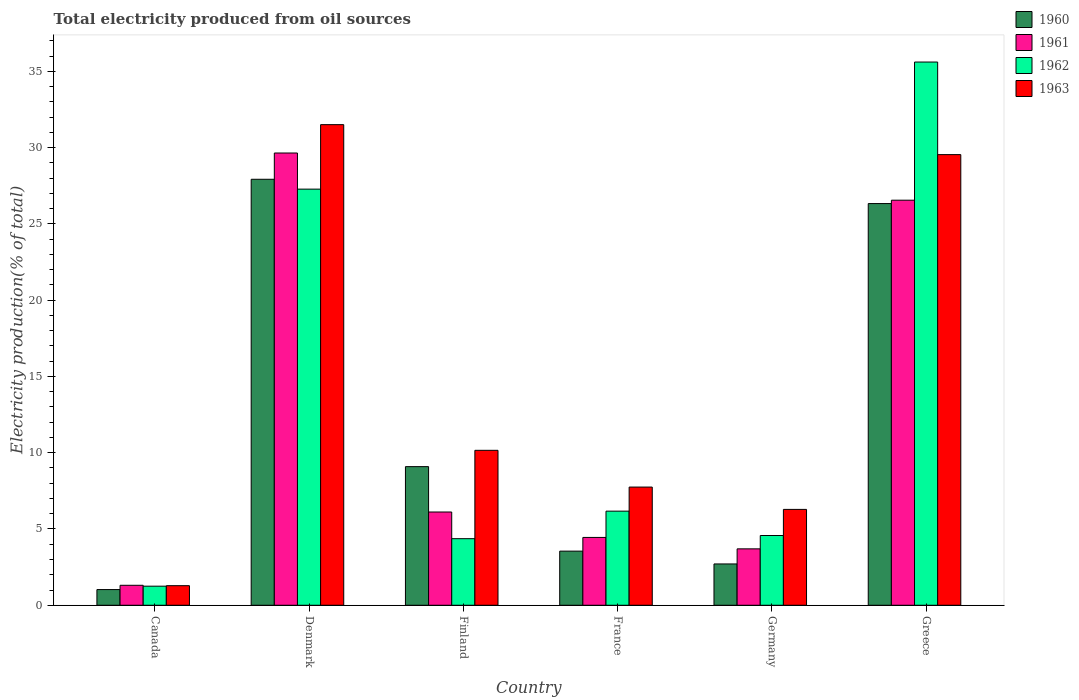How many groups of bars are there?
Provide a short and direct response. 6. Are the number of bars per tick equal to the number of legend labels?
Give a very brief answer. Yes. Are the number of bars on each tick of the X-axis equal?
Provide a succinct answer. Yes. How many bars are there on the 2nd tick from the left?
Your answer should be very brief. 4. How many bars are there on the 6th tick from the right?
Keep it short and to the point. 4. What is the total electricity produced in 1962 in Canada?
Your answer should be compact. 1.25. Across all countries, what is the maximum total electricity produced in 1960?
Your answer should be compact. 27.92. Across all countries, what is the minimum total electricity produced in 1963?
Your response must be concise. 1.28. In which country was the total electricity produced in 1960 minimum?
Provide a succinct answer. Canada. What is the total total electricity produced in 1960 in the graph?
Give a very brief answer. 70.63. What is the difference between the total electricity produced in 1961 in Denmark and that in Greece?
Keep it short and to the point. 3.09. What is the difference between the total electricity produced in 1960 in Canada and the total electricity produced in 1961 in Greece?
Provide a succinct answer. -25.52. What is the average total electricity produced in 1962 per country?
Offer a terse response. 13.21. What is the difference between the total electricity produced of/in 1960 and total electricity produced of/in 1962 in Germany?
Give a very brief answer. -1.86. In how many countries, is the total electricity produced in 1963 greater than 1 %?
Give a very brief answer. 6. What is the ratio of the total electricity produced in 1960 in Canada to that in Finland?
Provide a short and direct response. 0.11. Is the total electricity produced in 1962 in Canada less than that in Germany?
Keep it short and to the point. Yes. Is the difference between the total electricity produced in 1960 in Finland and Germany greater than the difference between the total electricity produced in 1962 in Finland and Germany?
Your answer should be very brief. Yes. What is the difference between the highest and the second highest total electricity produced in 1960?
Provide a short and direct response. -17.24. What is the difference between the highest and the lowest total electricity produced in 1963?
Provide a short and direct response. 30.22. In how many countries, is the total electricity produced in 1962 greater than the average total electricity produced in 1962 taken over all countries?
Your answer should be compact. 2. Is the sum of the total electricity produced in 1961 in Denmark and Germany greater than the maximum total electricity produced in 1962 across all countries?
Your answer should be very brief. No. What does the 1st bar from the right in Greece represents?
Your answer should be compact. 1963. How many bars are there?
Your answer should be compact. 24. Are all the bars in the graph horizontal?
Ensure brevity in your answer.  No. Are the values on the major ticks of Y-axis written in scientific E-notation?
Your answer should be very brief. No. Where does the legend appear in the graph?
Your answer should be compact. Top right. How many legend labels are there?
Your answer should be compact. 4. What is the title of the graph?
Your answer should be very brief. Total electricity produced from oil sources. What is the label or title of the Y-axis?
Your answer should be very brief. Electricity production(% of total). What is the Electricity production(% of total) in 1960 in Canada?
Ensure brevity in your answer.  1.03. What is the Electricity production(% of total) in 1961 in Canada?
Ensure brevity in your answer.  1.31. What is the Electricity production(% of total) in 1962 in Canada?
Offer a very short reply. 1.25. What is the Electricity production(% of total) of 1963 in Canada?
Offer a terse response. 1.28. What is the Electricity production(% of total) of 1960 in Denmark?
Give a very brief answer. 27.92. What is the Electricity production(% of total) in 1961 in Denmark?
Provide a succinct answer. 29.65. What is the Electricity production(% of total) in 1962 in Denmark?
Give a very brief answer. 27.28. What is the Electricity production(% of total) of 1963 in Denmark?
Your answer should be very brief. 31.51. What is the Electricity production(% of total) in 1960 in Finland?
Give a very brief answer. 9.09. What is the Electricity production(% of total) in 1961 in Finland?
Your response must be concise. 6.11. What is the Electricity production(% of total) of 1962 in Finland?
Provide a succinct answer. 4.36. What is the Electricity production(% of total) of 1963 in Finland?
Give a very brief answer. 10.16. What is the Electricity production(% of total) of 1960 in France?
Your answer should be very brief. 3.55. What is the Electricity production(% of total) of 1961 in France?
Your answer should be compact. 4.45. What is the Electricity production(% of total) of 1962 in France?
Provide a succinct answer. 6.17. What is the Electricity production(% of total) of 1963 in France?
Offer a terse response. 7.75. What is the Electricity production(% of total) of 1960 in Germany?
Keep it short and to the point. 2.71. What is the Electricity production(% of total) of 1961 in Germany?
Give a very brief answer. 3.7. What is the Electricity production(% of total) of 1962 in Germany?
Ensure brevity in your answer.  4.57. What is the Electricity production(% of total) in 1963 in Germany?
Provide a succinct answer. 6.28. What is the Electricity production(% of total) of 1960 in Greece?
Your answer should be compact. 26.33. What is the Electricity production(% of total) of 1961 in Greece?
Offer a very short reply. 26.55. What is the Electricity production(% of total) of 1962 in Greece?
Offer a terse response. 35.61. What is the Electricity production(% of total) in 1963 in Greece?
Keep it short and to the point. 29.54. Across all countries, what is the maximum Electricity production(% of total) of 1960?
Your answer should be compact. 27.92. Across all countries, what is the maximum Electricity production(% of total) in 1961?
Make the answer very short. 29.65. Across all countries, what is the maximum Electricity production(% of total) of 1962?
Provide a short and direct response. 35.61. Across all countries, what is the maximum Electricity production(% of total) in 1963?
Make the answer very short. 31.51. Across all countries, what is the minimum Electricity production(% of total) in 1960?
Ensure brevity in your answer.  1.03. Across all countries, what is the minimum Electricity production(% of total) in 1961?
Your response must be concise. 1.31. Across all countries, what is the minimum Electricity production(% of total) in 1962?
Your answer should be compact. 1.25. Across all countries, what is the minimum Electricity production(% of total) in 1963?
Offer a very short reply. 1.28. What is the total Electricity production(% of total) of 1960 in the graph?
Keep it short and to the point. 70.63. What is the total Electricity production(% of total) of 1961 in the graph?
Your response must be concise. 71.77. What is the total Electricity production(% of total) in 1962 in the graph?
Make the answer very short. 79.25. What is the total Electricity production(% of total) of 1963 in the graph?
Ensure brevity in your answer.  86.52. What is the difference between the Electricity production(% of total) in 1960 in Canada and that in Denmark?
Provide a succinct answer. -26.9. What is the difference between the Electricity production(% of total) in 1961 in Canada and that in Denmark?
Provide a succinct answer. -28.34. What is the difference between the Electricity production(% of total) in 1962 in Canada and that in Denmark?
Your response must be concise. -26.03. What is the difference between the Electricity production(% of total) in 1963 in Canada and that in Denmark?
Your answer should be very brief. -30.22. What is the difference between the Electricity production(% of total) in 1960 in Canada and that in Finland?
Your response must be concise. -8.06. What is the difference between the Electricity production(% of total) of 1961 in Canada and that in Finland?
Your answer should be very brief. -4.8. What is the difference between the Electricity production(% of total) of 1962 in Canada and that in Finland?
Offer a terse response. -3.11. What is the difference between the Electricity production(% of total) in 1963 in Canada and that in Finland?
Ensure brevity in your answer.  -8.87. What is the difference between the Electricity production(% of total) of 1960 in Canada and that in France?
Your answer should be very brief. -2.52. What is the difference between the Electricity production(% of total) of 1961 in Canada and that in France?
Your answer should be compact. -3.14. What is the difference between the Electricity production(% of total) of 1962 in Canada and that in France?
Your answer should be very brief. -4.92. What is the difference between the Electricity production(% of total) of 1963 in Canada and that in France?
Ensure brevity in your answer.  -6.46. What is the difference between the Electricity production(% of total) in 1960 in Canada and that in Germany?
Provide a succinct answer. -1.68. What is the difference between the Electricity production(% of total) in 1961 in Canada and that in Germany?
Your response must be concise. -2.39. What is the difference between the Electricity production(% of total) in 1962 in Canada and that in Germany?
Your answer should be very brief. -3.32. What is the difference between the Electricity production(% of total) of 1963 in Canada and that in Germany?
Your answer should be compact. -5. What is the difference between the Electricity production(% of total) in 1960 in Canada and that in Greece?
Make the answer very short. -25.3. What is the difference between the Electricity production(% of total) in 1961 in Canada and that in Greece?
Your answer should be compact. -25.24. What is the difference between the Electricity production(% of total) in 1962 in Canada and that in Greece?
Provide a succinct answer. -34.36. What is the difference between the Electricity production(% of total) in 1963 in Canada and that in Greece?
Ensure brevity in your answer.  -28.26. What is the difference between the Electricity production(% of total) of 1960 in Denmark and that in Finland?
Your response must be concise. 18.84. What is the difference between the Electricity production(% of total) in 1961 in Denmark and that in Finland?
Provide a succinct answer. 23.53. What is the difference between the Electricity production(% of total) in 1962 in Denmark and that in Finland?
Provide a succinct answer. 22.91. What is the difference between the Electricity production(% of total) in 1963 in Denmark and that in Finland?
Make the answer very short. 21.35. What is the difference between the Electricity production(% of total) in 1960 in Denmark and that in France?
Keep it short and to the point. 24.38. What is the difference between the Electricity production(% of total) of 1961 in Denmark and that in France?
Your answer should be compact. 25.2. What is the difference between the Electricity production(% of total) in 1962 in Denmark and that in France?
Give a very brief answer. 21.11. What is the difference between the Electricity production(% of total) of 1963 in Denmark and that in France?
Give a very brief answer. 23.76. What is the difference between the Electricity production(% of total) of 1960 in Denmark and that in Germany?
Ensure brevity in your answer.  25.22. What is the difference between the Electricity production(% of total) of 1961 in Denmark and that in Germany?
Your answer should be compact. 25.95. What is the difference between the Electricity production(% of total) in 1962 in Denmark and that in Germany?
Your response must be concise. 22.71. What is the difference between the Electricity production(% of total) of 1963 in Denmark and that in Germany?
Keep it short and to the point. 25.22. What is the difference between the Electricity production(% of total) in 1960 in Denmark and that in Greece?
Offer a terse response. 1.59. What is the difference between the Electricity production(% of total) in 1961 in Denmark and that in Greece?
Offer a terse response. 3.09. What is the difference between the Electricity production(% of total) of 1962 in Denmark and that in Greece?
Provide a succinct answer. -8.33. What is the difference between the Electricity production(% of total) in 1963 in Denmark and that in Greece?
Make the answer very short. 1.96. What is the difference between the Electricity production(% of total) in 1960 in Finland and that in France?
Provide a short and direct response. 5.54. What is the difference between the Electricity production(% of total) of 1961 in Finland and that in France?
Your response must be concise. 1.67. What is the difference between the Electricity production(% of total) of 1962 in Finland and that in France?
Ensure brevity in your answer.  -1.8. What is the difference between the Electricity production(% of total) of 1963 in Finland and that in France?
Make the answer very short. 2.41. What is the difference between the Electricity production(% of total) in 1960 in Finland and that in Germany?
Make the answer very short. 6.38. What is the difference between the Electricity production(% of total) of 1961 in Finland and that in Germany?
Keep it short and to the point. 2.41. What is the difference between the Electricity production(% of total) in 1962 in Finland and that in Germany?
Offer a very short reply. -0.21. What is the difference between the Electricity production(% of total) of 1963 in Finland and that in Germany?
Your response must be concise. 3.87. What is the difference between the Electricity production(% of total) of 1960 in Finland and that in Greece?
Provide a short and direct response. -17.24. What is the difference between the Electricity production(% of total) of 1961 in Finland and that in Greece?
Provide a short and direct response. -20.44. What is the difference between the Electricity production(% of total) in 1962 in Finland and that in Greece?
Provide a short and direct response. -31.25. What is the difference between the Electricity production(% of total) in 1963 in Finland and that in Greece?
Your response must be concise. -19.38. What is the difference between the Electricity production(% of total) in 1960 in France and that in Germany?
Give a very brief answer. 0.84. What is the difference between the Electricity production(% of total) in 1961 in France and that in Germany?
Keep it short and to the point. 0.75. What is the difference between the Electricity production(% of total) of 1962 in France and that in Germany?
Offer a terse response. 1.6. What is the difference between the Electricity production(% of total) in 1963 in France and that in Germany?
Your response must be concise. 1.46. What is the difference between the Electricity production(% of total) in 1960 in France and that in Greece?
Offer a very short reply. -22.78. What is the difference between the Electricity production(% of total) in 1961 in France and that in Greece?
Your answer should be very brief. -22.11. What is the difference between the Electricity production(% of total) of 1962 in France and that in Greece?
Offer a very short reply. -29.44. What is the difference between the Electricity production(% of total) in 1963 in France and that in Greece?
Make the answer very short. -21.79. What is the difference between the Electricity production(% of total) of 1960 in Germany and that in Greece?
Keep it short and to the point. -23.62. What is the difference between the Electricity production(% of total) of 1961 in Germany and that in Greece?
Your answer should be compact. -22.86. What is the difference between the Electricity production(% of total) of 1962 in Germany and that in Greece?
Your response must be concise. -31.04. What is the difference between the Electricity production(% of total) of 1963 in Germany and that in Greece?
Your answer should be very brief. -23.26. What is the difference between the Electricity production(% of total) of 1960 in Canada and the Electricity production(% of total) of 1961 in Denmark?
Make the answer very short. -28.62. What is the difference between the Electricity production(% of total) of 1960 in Canada and the Electricity production(% of total) of 1962 in Denmark?
Your answer should be very brief. -26.25. What is the difference between the Electricity production(% of total) of 1960 in Canada and the Electricity production(% of total) of 1963 in Denmark?
Provide a short and direct response. -30.48. What is the difference between the Electricity production(% of total) in 1961 in Canada and the Electricity production(% of total) in 1962 in Denmark?
Keep it short and to the point. -25.97. What is the difference between the Electricity production(% of total) in 1961 in Canada and the Electricity production(% of total) in 1963 in Denmark?
Your answer should be compact. -30.2. What is the difference between the Electricity production(% of total) in 1962 in Canada and the Electricity production(% of total) in 1963 in Denmark?
Offer a very short reply. -30.25. What is the difference between the Electricity production(% of total) of 1960 in Canada and the Electricity production(% of total) of 1961 in Finland?
Offer a very short reply. -5.08. What is the difference between the Electricity production(% of total) in 1960 in Canada and the Electricity production(% of total) in 1962 in Finland?
Offer a terse response. -3.34. What is the difference between the Electricity production(% of total) of 1960 in Canada and the Electricity production(% of total) of 1963 in Finland?
Provide a short and direct response. -9.13. What is the difference between the Electricity production(% of total) of 1961 in Canada and the Electricity production(% of total) of 1962 in Finland?
Your answer should be very brief. -3.06. What is the difference between the Electricity production(% of total) of 1961 in Canada and the Electricity production(% of total) of 1963 in Finland?
Give a very brief answer. -8.85. What is the difference between the Electricity production(% of total) in 1962 in Canada and the Electricity production(% of total) in 1963 in Finland?
Ensure brevity in your answer.  -8.91. What is the difference between the Electricity production(% of total) of 1960 in Canada and the Electricity production(% of total) of 1961 in France?
Provide a succinct answer. -3.42. What is the difference between the Electricity production(% of total) in 1960 in Canada and the Electricity production(% of total) in 1962 in France?
Give a very brief answer. -5.14. What is the difference between the Electricity production(% of total) in 1960 in Canada and the Electricity production(% of total) in 1963 in France?
Provide a short and direct response. -6.72. What is the difference between the Electricity production(% of total) of 1961 in Canada and the Electricity production(% of total) of 1962 in France?
Your answer should be compact. -4.86. What is the difference between the Electricity production(% of total) in 1961 in Canada and the Electricity production(% of total) in 1963 in France?
Provide a succinct answer. -6.44. What is the difference between the Electricity production(% of total) in 1962 in Canada and the Electricity production(% of total) in 1963 in France?
Give a very brief answer. -6.5. What is the difference between the Electricity production(% of total) in 1960 in Canada and the Electricity production(% of total) in 1961 in Germany?
Your answer should be compact. -2.67. What is the difference between the Electricity production(% of total) in 1960 in Canada and the Electricity production(% of total) in 1962 in Germany?
Your answer should be very brief. -3.54. What is the difference between the Electricity production(% of total) in 1960 in Canada and the Electricity production(% of total) in 1963 in Germany?
Provide a succinct answer. -5.26. What is the difference between the Electricity production(% of total) of 1961 in Canada and the Electricity production(% of total) of 1962 in Germany?
Your response must be concise. -3.26. What is the difference between the Electricity production(% of total) of 1961 in Canada and the Electricity production(% of total) of 1963 in Germany?
Give a very brief answer. -4.98. What is the difference between the Electricity production(% of total) in 1962 in Canada and the Electricity production(% of total) in 1963 in Germany?
Provide a succinct answer. -5.03. What is the difference between the Electricity production(% of total) in 1960 in Canada and the Electricity production(% of total) in 1961 in Greece?
Offer a very short reply. -25.52. What is the difference between the Electricity production(% of total) of 1960 in Canada and the Electricity production(% of total) of 1962 in Greece?
Keep it short and to the point. -34.58. What is the difference between the Electricity production(% of total) of 1960 in Canada and the Electricity production(% of total) of 1963 in Greece?
Offer a terse response. -28.51. What is the difference between the Electricity production(% of total) of 1961 in Canada and the Electricity production(% of total) of 1962 in Greece?
Your response must be concise. -34.3. What is the difference between the Electricity production(% of total) in 1961 in Canada and the Electricity production(% of total) in 1963 in Greece?
Your response must be concise. -28.23. What is the difference between the Electricity production(% of total) of 1962 in Canada and the Electricity production(% of total) of 1963 in Greece?
Your response must be concise. -28.29. What is the difference between the Electricity production(% of total) in 1960 in Denmark and the Electricity production(% of total) in 1961 in Finland?
Your answer should be compact. 21.81. What is the difference between the Electricity production(% of total) of 1960 in Denmark and the Electricity production(% of total) of 1962 in Finland?
Give a very brief answer. 23.56. What is the difference between the Electricity production(% of total) of 1960 in Denmark and the Electricity production(% of total) of 1963 in Finland?
Provide a short and direct response. 17.77. What is the difference between the Electricity production(% of total) in 1961 in Denmark and the Electricity production(% of total) in 1962 in Finland?
Make the answer very short. 25.28. What is the difference between the Electricity production(% of total) of 1961 in Denmark and the Electricity production(% of total) of 1963 in Finland?
Offer a terse response. 19.49. What is the difference between the Electricity production(% of total) in 1962 in Denmark and the Electricity production(% of total) in 1963 in Finland?
Your answer should be compact. 17.12. What is the difference between the Electricity production(% of total) in 1960 in Denmark and the Electricity production(% of total) in 1961 in France?
Ensure brevity in your answer.  23.48. What is the difference between the Electricity production(% of total) of 1960 in Denmark and the Electricity production(% of total) of 1962 in France?
Your answer should be compact. 21.75. What is the difference between the Electricity production(% of total) in 1960 in Denmark and the Electricity production(% of total) in 1963 in France?
Your answer should be very brief. 20.18. What is the difference between the Electricity production(% of total) in 1961 in Denmark and the Electricity production(% of total) in 1962 in France?
Your response must be concise. 23.48. What is the difference between the Electricity production(% of total) of 1961 in Denmark and the Electricity production(% of total) of 1963 in France?
Give a very brief answer. 21.9. What is the difference between the Electricity production(% of total) of 1962 in Denmark and the Electricity production(% of total) of 1963 in France?
Make the answer very short. 19.53. What is the difference between the Electricity production(% of total) in 1960 in Denmark and the Electricity production(% of total) in 1961 in Germany?
Keep it short and to the point. 24.23. What is the difference between the Electricity production(% of total) in 1960 in Denmark and the Electricity production(% of total) in 1962 in Germany?
Provide a succinct answer. 23.35. What is the difference between the Electricity production(% of total) of 1960 in Denmark and the Electricity production(% of total) of 1963 in Germany?
Offer a terse response. 21.64. What is the difference between the Electricity production(% of total) of 1961 in Denmark and the Electricity production(% of total) of 1962 in Germany?
Your answer should be very brief. 25.07. What is the difference between the Electricity production(% of total) of 1961 in Denmark and the Electricity production(% of total) of 1963 in Germany?
Provide a succinct answer. 23.36. What is the difference between the Electricity production(% of total) of 1962 in Denmark and the Electricity production(% of total) of 1963 in Germany?
Provide a short and direct response. 20.99. What is the difference between the Electricity production(% of total) in 1960 in Denmark and the Electricity production(% of total) in 1961 in Greece?
Your answer should be compact. 1.37. What is the difference between the Electricity production(% of total) in 1960 in Denmark and the Electricity production(% of total) in 1962 in Greece?
Provide a succinct answer. -7.69. What is the difference between the Electricity production(% of total) of 1960 in Denmark and the Electricity production(% of total) of 1963 in Greece?
Give a very brief answer. -1.62. What is the difference between the Electricity production(% of total) of 1961 in Denmark and the Electricity production(% of total) of 1962 in Greece?
Your answer should be compact. -5.96. What is the difference between the Electricity production(% of total) of 1961 in Denmark and the Electricity production(% of total) of 1963 in Greece?
Offer a terse response. 0.11. What is the difference between the Electricity production(% of total) of 1962 in Denmark and the Electricity production(% of total) of 1963 in Greece?
Your answer should be compact. -2.26. What is the difference between the Electricity production(% of total) of 1960 in Finland and the Electricity production(% of total) of 1961 in France?
Give a very brief answer. 4.64. What is the difference between the Electricity production(% of total) of 1960 in Finland and the Electricity production(% of total) of 1962 in France?
Your answer should be compact. 2.92. What is the difference between the Electricity production(% of total) in 1960 in Finland and the Electricity production(% of total) in 1963 in France?
Ensure brevity in your answer.  1.34. What is the difference between the Electricity production(% of total) in 1961 in Finland and the Electricity production(% of total) in 1962 in France?
Your answer should be very brief. -0.06. What is the difference between the Electricity production(% of total) of 1961 in Finland and the Electricity production(% of total) of 1963 in France?
Keep it short and to the point. -1.64. What is the difference between the Electricity production(% of total) of 1962 in Finland and the Electricity production(% of total) of 1963 in France?
Keep it short and to the point. -3.38. What is the difference between the Electricity production(% of total) in 1960 in Finland and the Electricity production(% of total) in 1961 in Germany?
Ensure brevity in your answer.  5.39. What is the difference between the Electricity production(% of total) of 1960 in Finland and the Electricity production(% of total) of 1962 in Germany?
Offer a very short reply. 4.51. What is the difference between the Electricity production(% of total) of 1960 in Finland and the Electricity production(% of total) of 1963 in Germany?
Your answer should be very brief. 2.8. What is the difference between the Electricity production(% of total) in 1961 in Finland and the Electricity production(% of total) in 1962 in Germany?
Offer a very short reply. 1.54. What is the difference between the Electricity production(% of total) of 1961 in Finland and the Electricity production(% of total) of 1963 in Germany?
Ensure brevity in your answer.  -0.17. What is the difference between the Electricity production(% of total) in 1962 in Finland and the Electricity production(% of total) in 1963 in Germany?
Keep it short and to the point. -1.92. What is the difference between the Electricity production(% of total) of 1960 in Finland and the Electricity production(% of total) of 1961 in Greece?
Offer a very short reply. -17.47. What is the difference between the Electricity production(% of total) of 1960 in Finland and the Electricity production(% of total) of 1962 in Greece?
Your answer should be very brief. -26.52. What is the difference between the Electricity production(% of total) in 1960 in Finland and the Electricity production(% of total) in 1963 in Greece?
Give a very brief answer. -20.45. What is the difference between the Electricity production(% of total) in 1961 in Finland and the Electricity production(% of total) in 1962 in Greece?
Give a very brief answer. -29.5. What is the difference between the Electricity production(% of total) of 1961 in Finland and the Electricity production(% of total) of 1963 in Greece?
Provide a short and direct response. -23.43. What is the difference between the Electricity production(% of total) in 1962 in Finland and the Electricity production(% of total) in 1963 in Greece?
Ensure brevity in your answer.  -25.18. What is the difference between the Electricity production(% of total) of 1960 in France and the Electricity production(% of total) of 1961 in Germany?
Your answer should be compact. -0.15. What is the difference between the Electricity production(% of total) in 1960 in France and the Electricity production(% of total) in 1962 in Germany?
Provide a succinct answer. -1.02. What is the difference between the Electricity production(% of total) of 1960 in France and the Electricity production(% of total) of 1963 in Germany?
Provide a short and direct response. -2.74. What is the difference between the Electricity production(% of total) in 1961 in France and the Electricity production(% of total) in 1962 in Germany?
Offer a terse response. -0.13. What is the difference between the Electricity production(% of total) of 1961 in France and the Electricity production(% of total) of 1963 in Germany?
Provide a short and direct response. -1.84. What is the difference between the Electricity production(% of total) of 1962 in France and the Electricity production(% of total) of 1963 in Germany?
Provide a succinct answer. -0.11. What is the difference between the Electricity production(% of total) of 1960 in France and the Electricity production(% of total) of 1961 in Greece?
Provide a succinct answer. -23.01. What is the difference between the Electricity production(% of total) of 1960 in France and the Electricity production(% of total) of 1962 in Greece?
Provide a short and direct response. -32.06. What is the difference between the Electricity production(% of total) of 1960 in France and the Electricity production(% of total) of 1963 in Greece?
Offer a terse response. -25.99. What is the difference between the Electricity production(% of total) in 1961 in France and the Electricity production(% of total) in 1962 in Greece?
Your response must be concise. -31.16. What is the difference between the Electricity production(% of total) of 1961 in France and the Electricity production(% of total) of 1963 in Greece?
Offer a very short reply. -25.09. What is the difference between the Electricity production(% of total) of 1962 in France and the Electricity production(% of total) of 1963 in Greece?
Your answer should be very brief. -23.37. What is the difference between the Electricity production(% of total) in 1960 in Germany and the Electricity production(% of total) in 1961 in Greece?
Keep it short and to the point. -23.85. What is the difference between the Electricity production(% of total) of 1960 in Germany and the Electricity production(% of total) of 1962 in Greece?
Your answer should be compact. -32.9. What is the difference between the Electricity production(% of total) of 1960 in Germany and the Electricity production(% of total) of 1963 in Greece?
Offer a very short reply. -26.83. What is the difference between the Electricity production(% of total) of 1961 in Germany and the Electricity production(% of total) of 1962 in Greece?
Your answer should be compact. -31.91. What is the difference between the Electricity production(% of total) in 1961 in Germany and the Electricity production(% of total) in 1963 in Greece?
Your answer should be very brief. -25.84. What is the difference between the Electricity production(% of total) of 1962 in Germany and the Electricity production(% of total) of 1963 in Greece?
Your response must be concise. -24.97. What is the average Electricity production(% of total) in 1960 per country?
Your answer should be compact. 11.77. What is the average Electricity production(% of total) in 1961 per country?
Your answer should be very brief. 11.96. What is the average Electricity production(% of total) of 1962 per country?
Ensure brevity in your answer.  13.21. What is the average Electricity production(% of total) of 1963 per country?
Make the answer very short. 14.42. What is the difference between the Electricity production(% of total) of 1960 and Electricity production(% of total) of 1961 in Canada?
Keep it short and to the point. -0.28. What is the difference between the Electricity production(% of total) in 1960 and Electricity production(% of total) in 1962 in Canada?
Give a very brief answer. -0.22. What is the difference between the Electricity production(% of total) in 1960 and Electricity production(% of total) in 1963 in Canada?
Your answer should be very brief. -0.26. What is the difference between the Electricity production(% of total) of 1961 and Electricity production(% of total) of 1962 in Canada?
Keep it short and to the point. 0.06. What is the difference between the Electricity production(% of total) in 1961 and Electricity production(% of total) in 1963 in Canada?
Provide a succinct answer. 0.03. What is the difference between the Electricity production(% of total) in 1962 and Electricity production(% of total) in 1963 in Canada?
Provide a short and direct response. -0.03. What is the difference between the Electricity production(% of total) of 1960 and Electricity production(% of total) of 1961 in Denmark?
Ensure brevity in your answer.  -1.72. What is the difference between the Electricity production(% of total) in 1960 and Electricity production(% of total) in 1962 in Denmark?
Ensure brevity in your answer.  0.65. What is the difference between the Electricity production(% of total) of 1960 and Electricity production(% of total) of 1963 in Denmark?
Offer a very short reply. -3.58. What is the difference between the Electricity production(% of total) of 1961 and Electricity production(% of total) of 1962 in Denmark?
Your answer should be very brief. 2.37. What is the difference between the Electricity production(% of total) of 1961 and Electricity production(% of total) of 1963 in Denmark?
Provide a short and direct response. -1.86. What is the difference between the Electricity production(% of total) in 1962 and Electricity production(% of total) in 1963 in Denmark?
Offer a terse response. -4.23. What is the difference between the Electricity production(% of total) of 1960 and Electricity production(% of total) of 1961 in Finland?
Offer a very short reply. 2.98. What is the difference between the Electricity production(% of total) of 1960 and Electricity production(% of total) of 1962 in Finland?
Your answer should be very brief. 4.72. What is the difference between the Electricity production(% of total) of 1960 and Electricity production(% of total) of 1963 in Finland?
Your response must be concise. -1.07. What is the difference between the Electricity production(% of total) in 1961 and Electricity production(% of total) in 1962 in Finland?
Make the answer very short. 1.75. What is the difference between the Electricity production(% of total) of 1961 and Electricity production(% of total) of 1963 in Finland?
Offer a terse response. -4.04. What is the difference between the Electricity production(% of total) in 1962 and Electricity production(% of total) in 1963 in Finland?
Keep it short and to the point. -5.79. What is the difference between the Electricity production(% of total) of 1960 and Electricity production(% of total) of 1961 in France?
Provide a succinct answer. -0.9. What is the difference between the Electricity production(% of total) of 1960 and Electricity production(% of total) of 1962 in France?
Give a very brief answer. -2.62. What is the difference between the Electricity production(% of total) in 1960 and Electricity production(% of total) in 1963 in France?
Offer a very short reply. -4.2. What is the difference between the Electricity production(% of total) of 1961 and Electricity production(% of total) of 1962 in France?
Offer a very short reply. -1.72. What is the difference between the Electricity production(% of total) in 1961 and Electricity production(% of total) in 1963 in France?
Your response must be concise. -3.3. What is the difference between the Electricity production(% of total) of 1962 and Electricity production(% of total) of 1963 in France?
Make the answer very short. -1.58. What is the difference between the Electricity production(% of total) of 1960 and Electricity production(% of total) of 1961 in Germany?
Keep it short and to the point. -0.99. What is the difference between the Electricity production(% of total) of 1960 and Electricity production(% of total) of 1962 in Germany?
Your answer should be compact. -1.86. What is the difference between the Electricity production(% of total) of 1960 and Electricity production(% of total) of 1963 in Germany?
Ensure brevity in your answer.  -3.58. What is the difference between the Electricity production(% of total) in 1961 and Electricity production(% of total) in 1962 in Germany?
Ensure brevity in your answer.  -0.87. What is the difference between the Electricity production(% of total) in 1961 and Electricity production(% of total) in 1963 in Germany?
Offer a terse response. -2.59. What is the difference between the Electricity production(% of total) in 1962 and Electricity production(% of total) in 1963 in Germany?
Offer a terse response. -1.71. What is the difference between the Electricity production(% of total) of 1960 and Electricity production(% of total) of 1961 in Greece?
Provide a succinct answer. -0.22. What is the difference between the Electricity production(% of total) of 1960 and Electricity production(% of total) of 1962 in Greece?
Offer a very short reply. -9.28. What is the difference between the Electricity production(% of total) in 1960 and Electricity production(% of total) in 1963 in Greece?
Offer a very short reply. -3.21. What is the difference between the Electricity production(% of total) of 1961 and Electricity production(% of total) of 1962 in Greece?
Your response must be concise. -9.06. What is the difference between the Electricity production(% of total) of 1961 and Electricity production(% of total) of 1963 in Greece?
Your answer should be very brief. -2.99. What is the difference between the Electricity production(% of total) in 1962 and Electricity production(% of total) in 1963 in Greece?
Keep it short and to the point. 6.07. What is the ratio of the Electricity production(% of total) in 1960 in Canada to that in Denmark?
Provide a succinct answer. 0.04. What is the ratio of the Electricity production(% of total) of 1961 in Canada to that in Denmark?
Your answer should be very brief. 0.04. What is the ratio of the Electricity production(% of total) of 1962 in Canada to that in Denmark?
Provide a short and direct response. 0.05. What is the ratio of the Electricity production(% of total) in 1963 in Canada to that in Denmark?
Make the answer very short. 0.04. What is the ratio of the Electricity production(% of total) of 1960 in Canada to that in Finland?
Your response must be concise. 0.11. What is the ratio of the Electricity production(% of total) in 1961 in Canada to that in Finland?
Provide a short and direct response. 0.21. What is the ratio of the Electricity production(% of total) in 1962 in Canada to that in Finland?
Provide a succinct answer. 0.29. What is the ratio of the Electricity production(% of total) of 1963 in Canada to that in Finland?
Your answer should be very brief. 0.13. What is the ratio of the Electricity production(% of total) in 1960 in Canada to that in France?
Your response must be concise. 0.29. What is the ratio of the Electricity production(% of total) in 1961 in Canada to that in France?
Your response must be concise. 0.29. What is the ratio of the Electricity production(% of total) of 1962 in Canada to that in France?
Give a very brief answer. 0.2. What is the ratio of the Electricity production(% of total) in 1963 in Canada to that in France?
Your response must be concise. 0.17. What is the ratio of the Electricity production(% of total) of 1960 in Canada to that in Germany?
Provide a short and direct response. 0.38. What is the ratio of the Electricity production(% of total) in 1961 in Canada to that in Germany?
Keep it short and to the point. 0.35. What is the ratio of the Electricity production(% of total) in 1962 in Canada to that in Germany?
Your answer should be compact. 0.27. What is the ratio of the Electricity production(% of total) of 1963 in Canada to that in Germany?
Provide a short and direct response. 0.2. What is the ratio of the Electricity production(% of total) in 1960 in Canada to that in Greece?
Offer a terse response. 0.04. What is the ratio of the Electricity production(% of total) of 1961 in Canada to that in Greece?
Your answer should be compact. 0.05. What is the ratio of the Electricity production(% of total) in 1962 in Canada to that in Greece?
Your response must be concise. 0.04. What is the ratio of the Electricity production(% of total) in 1963 in Canada to that in Greece?
Ensure brevity in your answer.  0.04. What is the ratio of the Electricity production(% of total) in 1960 in Denmark to that in Finland?
Keep it short and to the point. 3.07. What is the ratio of the Electricity production(% of total) of 1961 in Denmark to that in Finland?
Offer a very short reply. 4.85. What is the ratio of the Electricity production(% of total) in 1962 in Denmark to that in Finland?
Your answer should be very brief. 6.25. What is the ratio of the Electricity production(% of total) in 1963 in Denmark to that in Finland?
Offer a very short reply. 3.1. What is the ratio of the Electricity production(% of total) in 1960 in Denmark to that in France?
Your response must be concise. 7.87. What is the ratio of the Electricity production(% of total) of 1961 in Denmark to that in France?
Your answer should be very brief. 6.67. What is the ratio of the Electricity production(% of total) of 1962 in Denmark to that in France?
Provide a short and direct response. 4.42. What is the ratio of the Electricity production(% of total) of 1963 in Denmark to that in France?
Your answer should be very brief. 4.07. What is the ratio of the Electricity production(% of total) of 1960 in Denmark to that in Germany?
Your response must be concise. 10.31. What is the ratio of the Electricity production(% of total) of 1961 in Denmark to that in Germany?
Provide a short and direct response. 8.02. What is the ratio of the Electricity production(% of total) in 1962 in Denmark to that in Germany?
Your response must be concise. 5.97. What is the ratio of the Electricity production(% of total) of 1963 in Denmark to that in Germany?
Provide a succinct answer. 5.01. What is the ratio of the Electricity production(% of total) of 1960 in Denmark to that in Greece?
Your answer should be very brief. 1.06. What is the ratio of the Electricity production(% of total) of 1961 in Denmark to that in Greece?
Ensure brevity in your answer.  1.12. What is the ratio of the Electricity production(% of total) in 1962 in Denmark to that in Greece?
Make the answer very short. 0.77. What is the ratio of the Electricity production(% of total) of 1963 in Denmark to that in Greece?
Give a very brief answer. 1.07. What is the ratio of the Electricity production(% of total) of 1960 in Finland to that in France?
Your answer should be very brief. 2.56. What is the ratio of the Electricity production(% of total) of 1961 in Finland to that in France?
Your answer should be compact. 1.37. What is the ratio of the Electricity production(% of total) in 1962 in Finland to that in France?
Your response must be concise. 0.71. What is the ratio of the Electricity production(% of total) in 1963 in Finland to that in France?
Your answer should be very brief. 1.31. What is the ratio of the Electricity production(% of total) of 1960 in Finland to that in Germany?
Offer a terse response. 3.36. What is the ratio of the Electricity production(% of total) of 1961 in Finland to that in Germany?
Give a very brief answer. 1.65. What is the ratio of the Electricity production(% of total) of 1962 in Finland to that in Germany?
Provide a short and direct response. 0.95. What is the ratio of the Electricity production(% of total) in 1963 in Finland to that in Germany?
Provide a succinct answer. 1.62. What is the ratio of the Electricity production(% of total) of 1960 in Finland to that in Greece?
Make the answer very short. 0.35. What is the ratio of the Electricity production(% of total) of 1961 in Finland to that in Greece?
Make the answer very short. 0.23. What is the ratio of the Electricity production(% of total) in 1962 in Finland to that in Greece?
Keep it short and to the point. 0.12. What is the ratio of the Electricity production(% of total) in 1963 in Finland to that in Greece?
Offer a terse response. 0.34. What is the ratio of the Electricity production(% of total) of 1960 in France to that in Germany?
Offer a very short reply. 1.31. What is the ratio of the Electricity production(% of total) of 1961 in France to that in Germany?
Give a very brief answer. 1.2. What is the ratio of the Electricity production(% of total) in 1962 in France to that in Germany?
Provide a short and direct response. 1.35. What is the ratio of the Electricity production(% of total) in 1963 in France to that in Germany?
Your answer should be compact. 1.23. What is the ratio of the Electricity production(% of total) in 1960 in France to that in Greece?
Provide a short and direct response. 0.13. What is the ratio of the Electricity production(% of total) in 1961 in France to that in Greece?
Make the answer very short. 0.17. What is the ratio of the Electricity production(% of total) in 1962 in France to that in Greece?
Make the answer very short. 0.17. What is the ratio of the Electricity production(% of total) in 1963 in France to that in Greece?
Keep it short and to the point. 0.26. What is the ratio of the Electricity production(% of total) in 1960 in Germany to that in Greece?
Keep it short and to the point. 0.1. What is the ratio of the Electricity production(% of total) in 1961 in Germany to that in Greece?
Your response must be concise. 0.14. What is the ratio of the Electricity production(% of total) in 1962 in Germany to that in Greece?
Make the answer very short. 0.13. What is the ratio of the Electricity production(% of total) of 1963 in Germany to that in Greece?
Keep it short and to the point. 0.21. What is the difference between the highest and the second highest Electricity production(% of total) of 1960?
Your answer should be very brief. 1.59. What is the difference between the highest and the second highest Electricity production(% of total) of 1961?
Your answer should be very brief. 3.09. What is the difference between the highest and the second highest Electricity production(% of total) of 1962?
Keep it short and to the point. 8.33. What is the difference between the highest and the second highest Electricity production(% of total) of 1963?
Offer a very short reply. 1.96. What is the difference between the highest and the lowest Electricity production(% of total) in 1960?
Your response must be concise. 26.9. What is the difference between the highest and the lowest Electricity production(% of total) of 1961?
Offer a very short reply. 28.34. What is the difference between the highest and the lowest Electricity production(% of total) of 1962?
Offer a very short reply. 34.36. What is the difference between the highest and the lowest Electricity production(% of total) of 1963?
Your response must be concise. 30.22. 